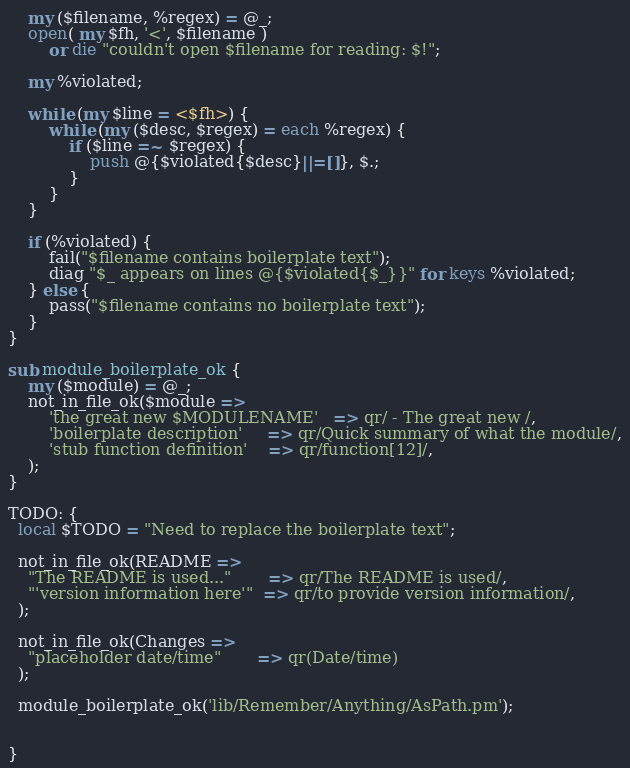<code> <loc_0><loc_0><loc_500><loc_500><_Perl_>    my ($filename, %regex) = @_;
    open( my $fh, '<', $filename )
        or die "couldn't open $filename for reading: $!";

    my %violated;

    while (my $line = <$fh>) {
        while (my ($desc, $regex) = each %regex) {
            if ($line =~ $regex) {
                push @{$violated{$desc}||=[]}, $.;
            }
        }
    }

    if (%violated) {
        fail("$filename contains boilerplate text");
        diag "$_ appears on lines @{$violated{$_}}" for keys %violated;
    } else {
        pass("$filename contains no boilerplate text");
    }
}

sub module_boilerplate_ok {
    my ($module) = @_;
    not_in_file_ok($module =>
        'the great new $MODULENAME'   => qr/ - The great new /,
        'boilerplate description'     => qr/Quick summary of what the module/,
        'stub function definition'    => qr/function[12]/,
    );
}

TODO: {
  local $TODO = "Need to replace the boilerplate text";

  not_in_file_ok(README =>
    "The README is used..."       => qr/The README is used/,
    "'version information here'"  => qr/to provide version information/,
  );

  not_in_file_ok(Changes =>
    "placeholder date/time"       => qr(Date/time)
  );

  module_boilerplate_ok('lib/Remember/Anything/AsPath.pm');


}

</code> 